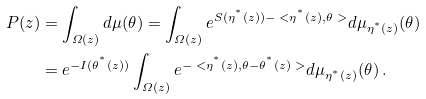Convert formula to latex. <formula><loc_0><loc_0><loc_500><loc_500>P ( z ) & = \int _ { \varOmega ( z ) } d \mu ( \theta ) = \int _ { \varOmega ( z ) } e ^ { S ( \eta ^ { ^ { * } } ( z ) ) - \ < \eta ^ { ^ { * } } ( z ) , \theta \ > } d \mu _ { \eta ^ { ^ { * } } ( z ) } ( \theta ) \\ & = e ^ { - I ( \theta ^ { ^ { * } } ( z ) ) } \int _ { \varOmega ( z ) } e ^ { - \ < \eta ^ { ^ { * } } ( z ) , \theta - \theta ^ { ^ { * } } ( z ) \ > } d \mu _ { \eta ^ { ^ { * } } ( z ) } ( \theta ) \, .</formula> 